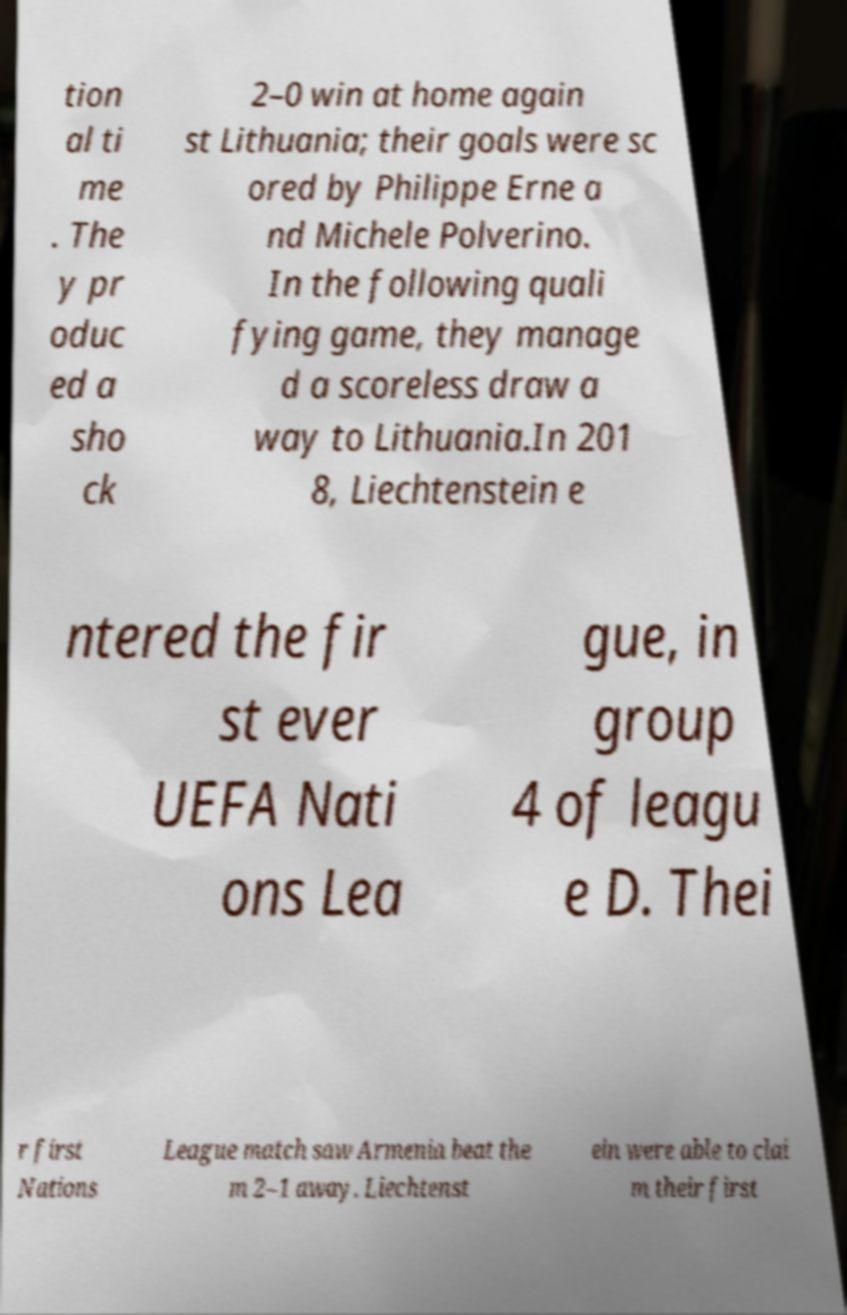I need the written content from this picture converted into text. Can you do that? tion al ti me . The y pr oduc ed a sho ck 2–0 win at home again st Lithuania; their goals were sc ored by Philippe Erne a nd Michele Polverino. In the following quali fying game, they manage d a scoreless draw a way to Lithuania.In 201 8, Liechtenstein e ntered the fir st ever UEFA Nati ons Lea gue, in group 4 of leagu e D. Thei r first Nations League match saw Armenia beat the m 2–1 away. Liechtenst ein were able to clai m their first 